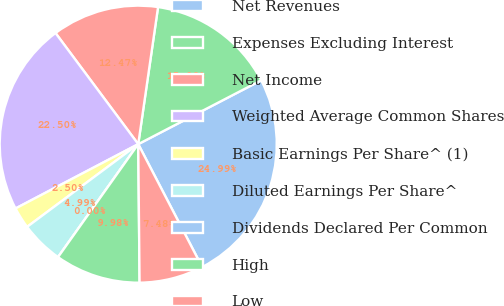Convert chart. <chart><loc_0><loc_0><loc_500><loc_500><pie_chart><fcel>Net Revenues<fcel>Expenses Excluding Interest<fcel>Net Income<fcel>Weighted Average Common Shares<fcel>Basic Earnings Per Share^ (1)<fcel>Diluted Earnings Per Share^<fcel>Dividends Declared Per Common<fcel>High<fcel>Low<nl><fcel>24.99%<fcel>15.09%<fcel>12.47%<fcel>22.5%<fcel>2.5%<fcel>4.99%<fcel>0.0%<fcel>9.98%<fcel>7.48%<nl></chart> 